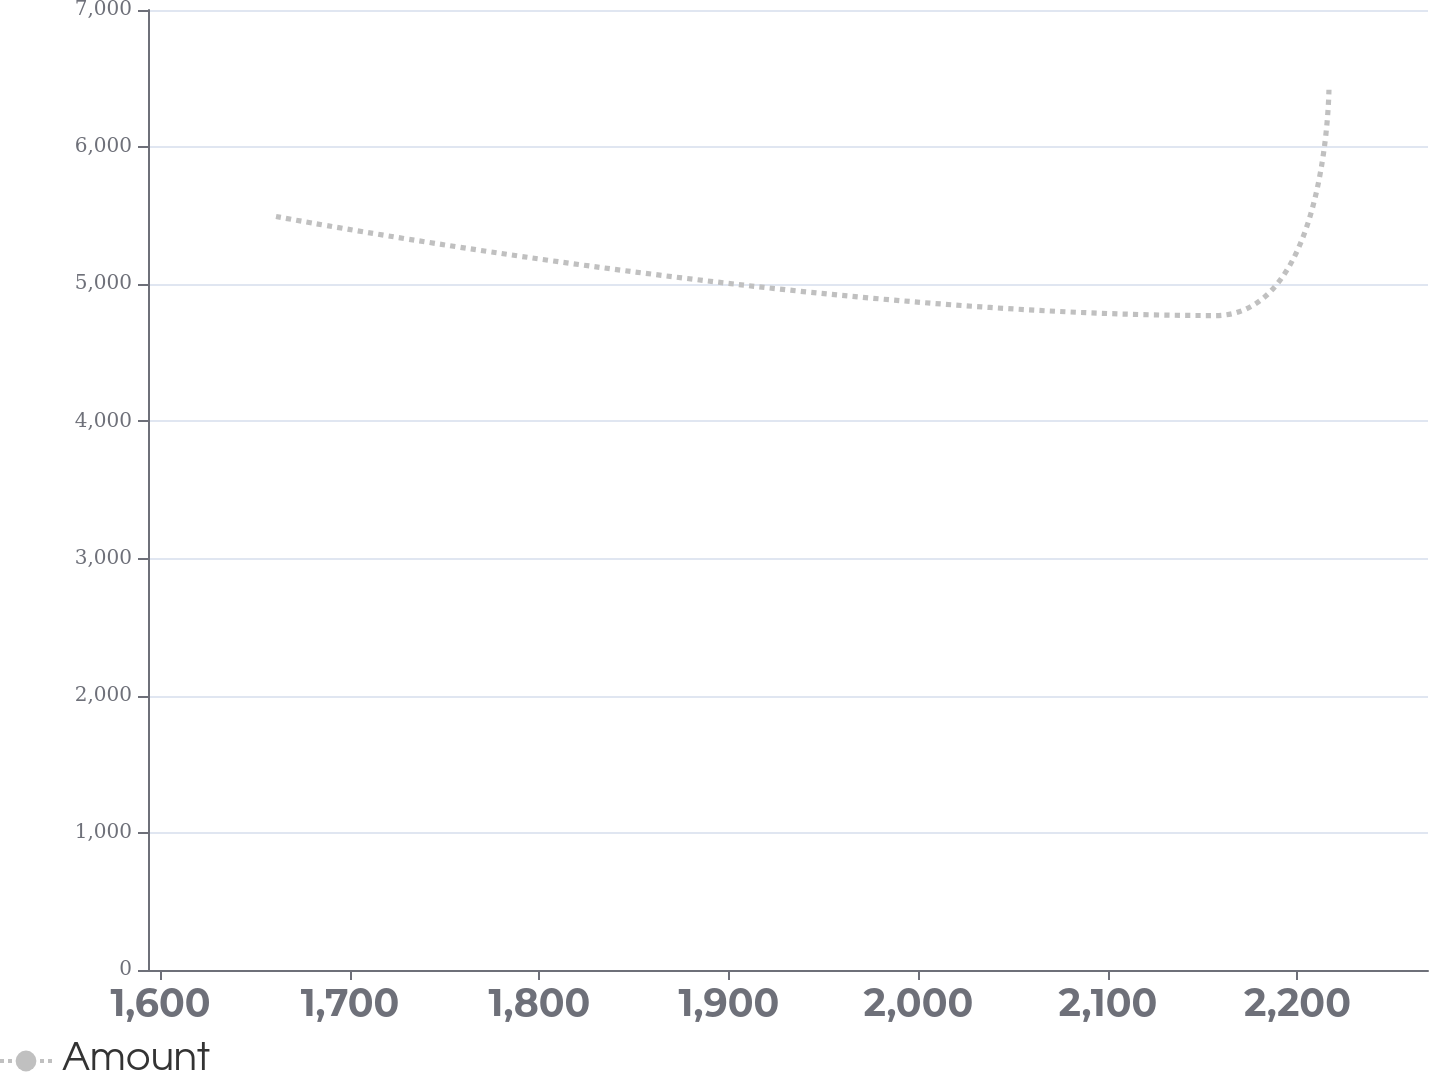<chart> <loc_0><loc_0><loc_500><loc_500><line_chart><ecel><fcel>Amount<nl><fcel>1660.97<fcel>5494.32<nl><fcel>2156.73<fcel>4771.94<nl><fcel>2216.64<fcel>6418.52<nl><fcel>2276.55<fcel>6137.31<nl><fcel>2336.46<fcel>5658.98<nl></chart> 